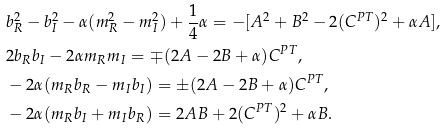<formula> <loc_0><loc_0><loc_500><loc_500>& b _ { R } ^ { 2 } - b _ { I } ^ { 2 } - \alpha ( m _ { R } ^ { 2 } - m _ { I } ^ { 2 } ) + \frac { 1 } { 4 } \alpha = - [ A ^ { 2 } + B ^ { 2 } - 2 ( C ^ { P T } ) ^ { 2 } + \alpha A ] , \\ & 2 b _ { R } b _ { I } - 2 \alpha m _ { R } m _ { I } = \mp ( 2 A - 2 B + \alpha ) C ^ { P T } , \\ & - 2 \alpha ( m _ { R } b _ { R } - m _ { I } b _ { I } ) = \pm ( 2 A - 2 B + \alpha ) C ^ { P T } , \\ & - 2 \alpha ( m _ { R } b _ { I } + m _ { I } b _ { R } ) = 2 A B + 2 ( C ^ { P T } ) ^ { 2 } + \alpha B .</formula> 